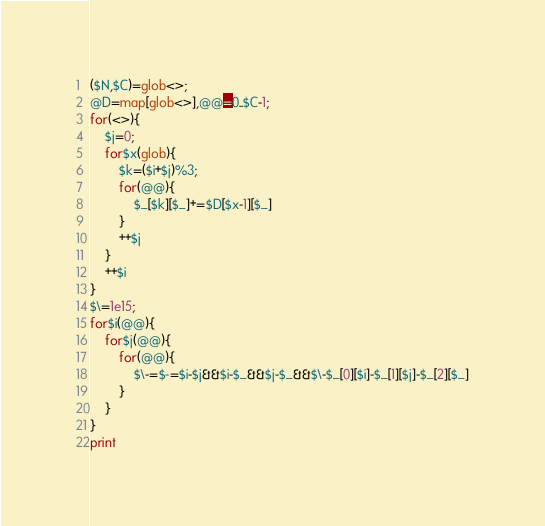<code> <loc_0><loc_0><loc_500><loc_500><_Perl_>($N,$C)=glob<>;
@D=map[glob<>],@@=0..$C-1;
for(<>){
	$j=0;
	for$x(glob){
		$k=($i+$j)%3;
		for(@@){
			$_[$k][$_]+=$D[$x-1][$_]
		}
		++$j
	}
	++$i
}
$\=1e15;
for$i(@@){
	for$j(@@){
		for(@@){
			$\-=$-=$i-$j&&$i-$_&&$j-$_&&$\-$_[0][$i]-$_[1][$j]-$_[2][$_]
		}
	}
}
print
</code> 